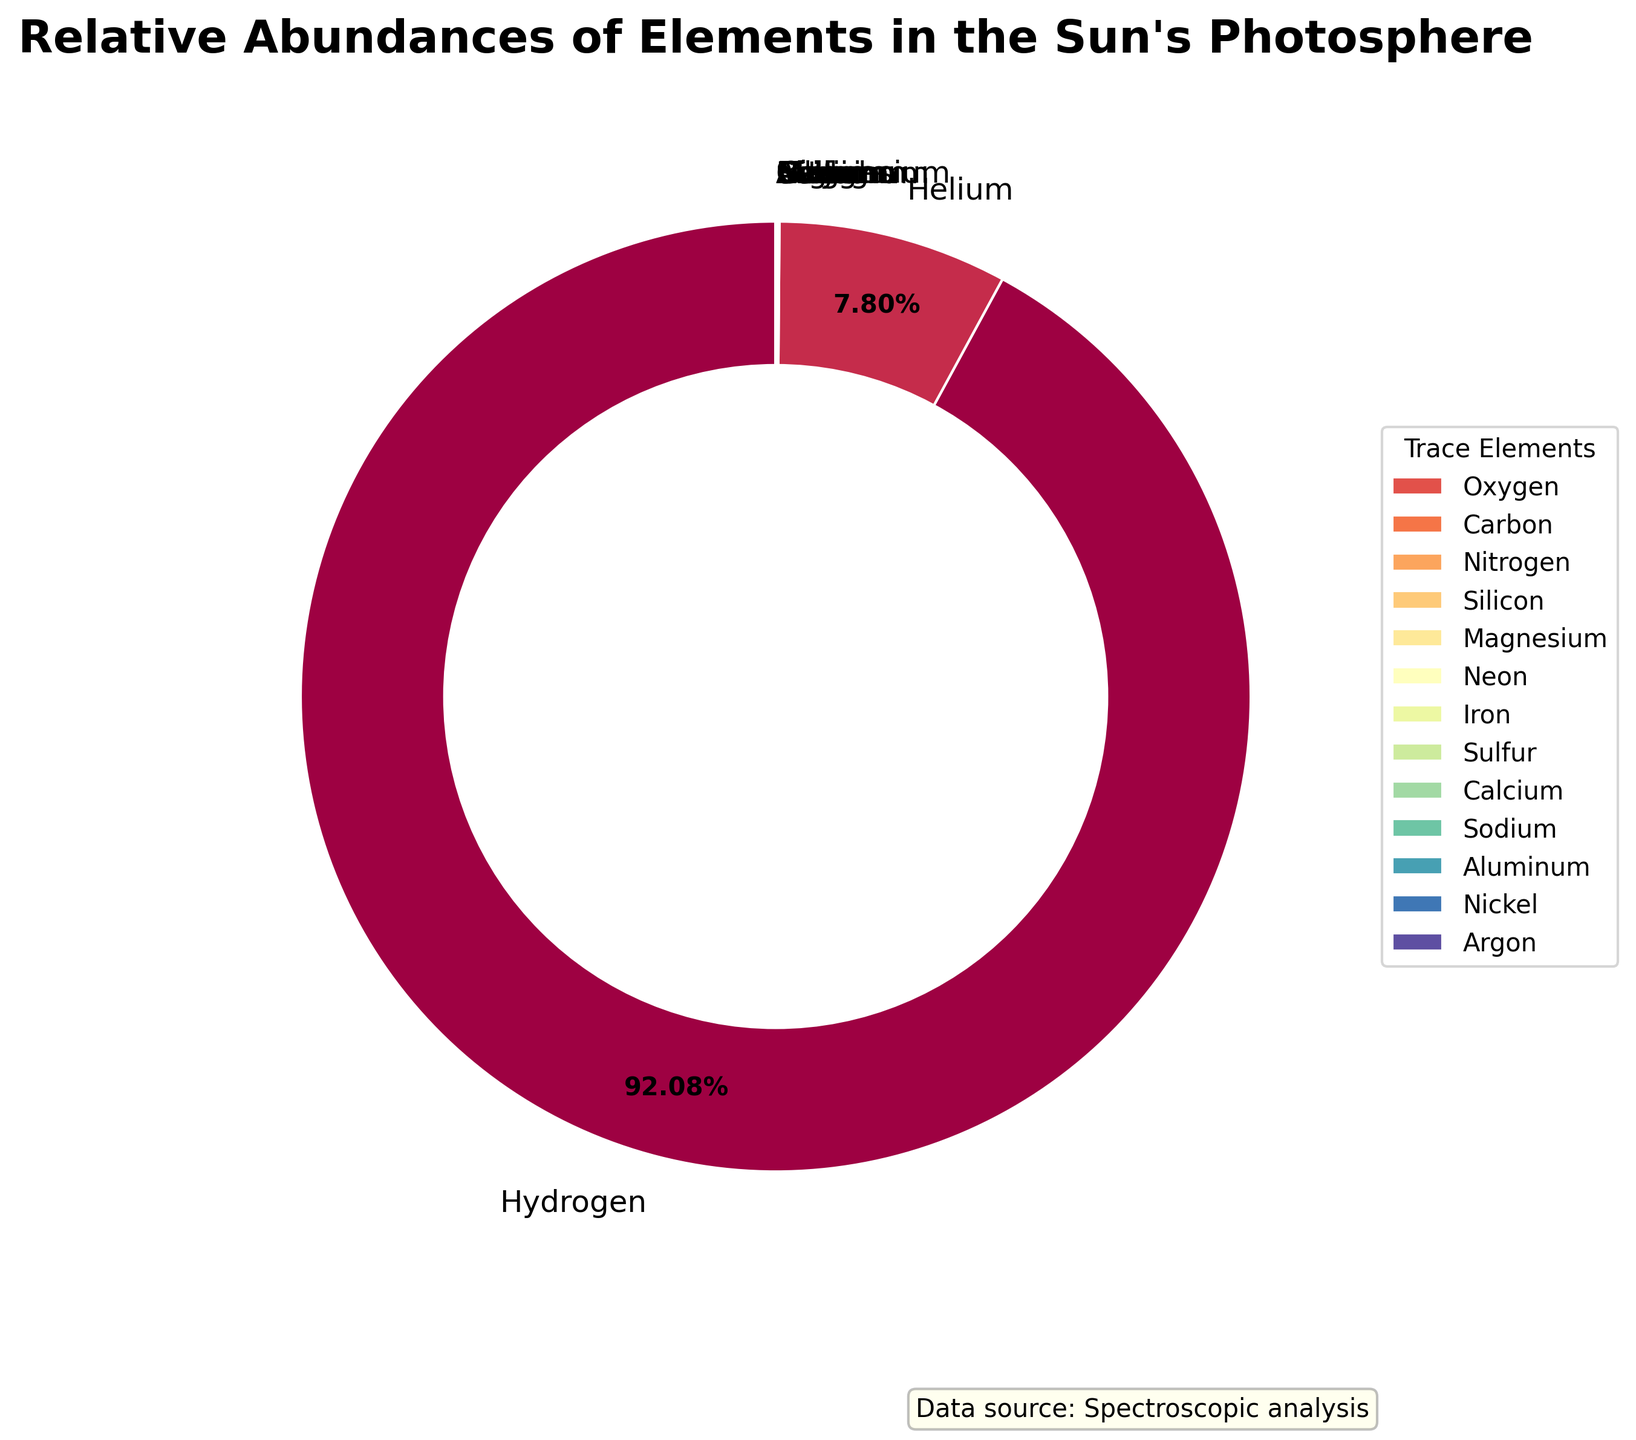What is the relative abundance of Hydrogen in the Sun's photosphere? The pie chart shows various elements with their relative abundances. We can see that Hydrogen has the largest portion, labeled as 92.1%.
Answer: 92.1% Which element has the second highest relative abundance after Hydrogen? By examining the pie chart, we notice that the second largest section is labeled for Helium, with a relative abundance of 7.8%.
Answer: Helium What is the combined relative abundance of Oxygen, Carbon, and Nitrogen? From the pie chart, the relative abundances are Oxygen: 0.061%, Carbon: 0.03%, and Nitrogen: 0.0084%. Adding these gives us 0.061 + 0.03 + 0.0084 = 0.0994%.
Answer: 0.0994% How does the relative abundance of Iron compare to that of Silicon? Observing the pie chart, Silicon has a relative abundance of 0.0065%, while Iron has 0.0047%. Iron's abundance is less than Silicon's abundance.
Answer: Less Which trace elements are indicated in the legend, and what are their combined relative abundances? The legend shows trace elements with small relative abundances. These include Sulfur, Calcium, Sodium, Aluminum, Nickel, and Argon. Their relative abundances are Sulfur: 0.0015%, Calcium: 0.0006%, Sodium: 0.0002%, Aluminum: 0.0002%, Nickel: 0.00008%, and Argon: 0.00005%. Adding them together gives 0.00268%.
Answer: Sulfur, Calcium, Sodium, Aluminum, Nickel, Argon, 0.00268% Which element has the smallest relative abundance, and what is it? By looking at the pie chart, it is clear that Argon has the smallest section, labeled with a relative abundance of 0.00005%.
Answer: Argon, 0.00005% If you combine the relative abundances of Magnesium and Neon, how does their total compare to the relative abundance of Carbon? The pie chart shows Magnesium with 0.0058% and Neon with 0.0056%. Summing them gives 0.0058 + 0.0056 = 0.0114%. This is significantly larger than Carbon's 0.03%.
Answer: Larger What visual attribute distinguishes the element with the highest abundance in the pie chart? The pie chart distinguishes Hydrogen as the highest abundance with the largest sector, occupying the majority of the circle.
Answer: Largest sector Is the sum of the relative abundances of Sulfur and Calcium greater than the sum of the relative abundances of Nitrogen and Silicon? From the pie chart, Sulfur is 0.0015% and Calcium is 0.0006%, summing to 0.0021%. Nitrogen is 0.0084% and Silicon is 0.0065%, summing to 0.0149%. 0.0021% is less than 0.0149%.
Answer: No Which three elements after Hydrogen and Helium have the highest relative abundances? Observing the pie chart, after Hydrogen and Helium, the next largest sections are for Oxygen (0.061%), Carbon (0.03%), and Nitrogen (0.0084%).
Answer: Oxygen, Carbon, Nitrogen 